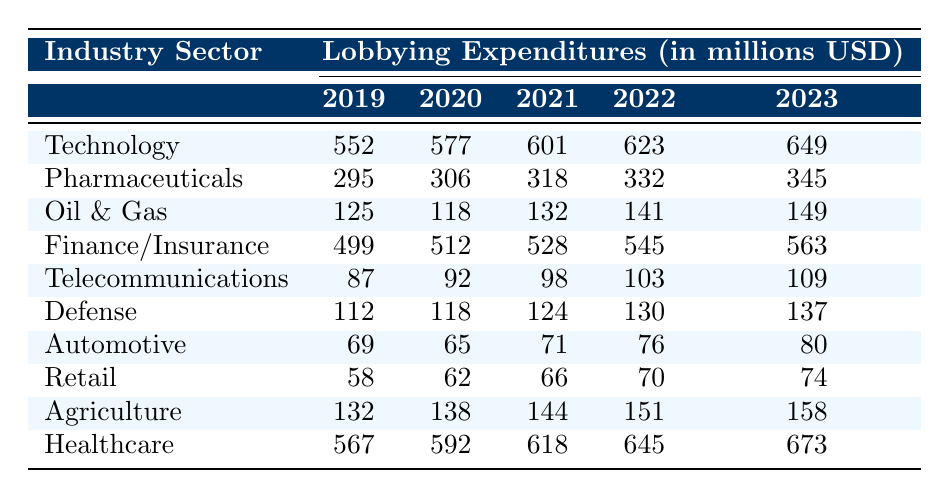What was the lobbying expenditure for the Technology sector in 2021? The table shows the value for the Technology sector in 2021 as $601M.
Answer: $601M Which industry sector had the highest lobbying expenditure in 2023? By reviewing the last column for 2023, Healthcare has the highest expenditure at $673M.
Answer: $673M What is the total lobbying expenditure for Pharmaceuticals from 2019 to 2023? Summing the values: $295M + $306M + $318M + $332M + $345M = $1,596M.
Answer: $1,596M Was the lobbying expenditure for Oil & Gas higher in 2019 than in 2020? Comparing the values: $125M in 2019 is greater than $118M in 2020, so the statement is true.
Answer: Yes What is the average lobbying expenditure of the Automotive sector from 2019 to 2023? To find the average: ($69M + $65M + $71M + $76M + $80M) / 5 = $72.2M.
Answer: $72.2M Which industry sector saw the smallest increase in lobbying expenditures between 2022 and 2023? By comparing the last two years' values: Oil & Gas increased by $8M, while others increased by more. The smallest is Oil & Gas.
Answer: Oil & Gas Is the total lobbying expenditure of the Finance/Insurance sector higher than that of the Pharmaceuticals sector for 2021? Comparing the two: Finance/Insurance is $528M and Pharmaceuticals is $318M, hence it is higher.
Answer: Yes Calculate the percentage increase in lobbying expenditures for the Defense sector from 2019 to 2023. The increase is $137M - $112M = $25M. To find the percentage: ($25M / $112M) * 100 = 22.32%.
Answer: 22.32% Which industry sector had a lobbying expenditure of $149M in 2023? By checking the last column of the table, it shows that Oil & Gas matches this value.
Answer: Oil & Gas 